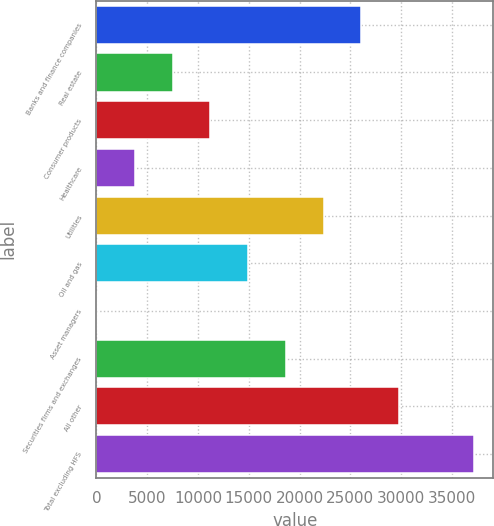<chart> <loc_0><loc_0><loc_500><loc_500><bar_chart><fcel>Banks and finance companies<fcel>Real estate<fcel>Consumer products<fcel>Healthcare<fcel>Utilities<fcel>Oil and gas<fcel>Asset managers<fcel>Securities firms and exchanges<fcel>All other<fcel>Total excluding HFS<nl><fcel>26064<fcel>7504<fcel>11216<fcel>3792<fcel>22352<fcel>14928<fcel>80<fcel>18640<fcel>29776<fcel>37200<nl></chart> 